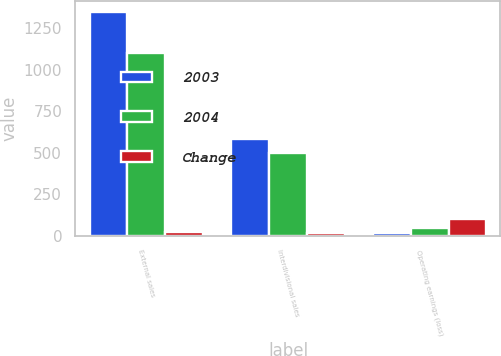Convert chart to OTSL. <chart><loc_0><loc_0><loc_500><loc_500><stacked_bar_chart><ecel><fcel>External sales<fcel>Interdivisional sales<fcel>Operating earnings (loss)<nl><fcel>2003<fcel>1347<fcel>583<fcel>16<nl><fcel>2004<fcel>1098<fcel>495<fcel>45<nl><fcel>Change<fcel>23<fcel>18<fcel>100<nl></chart> 